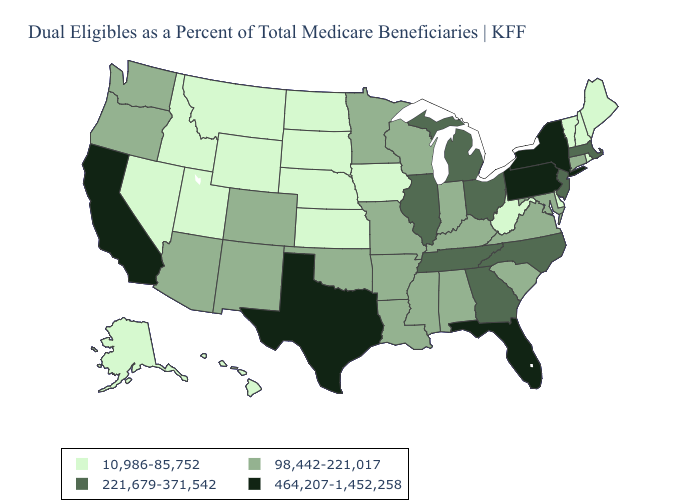Name the states that have a value in the range 221,679-371,542?
Answer briefly. Georgia, Illinois, Massachusetts, Michigan, New Jersey, North Carolina, Ohio, Tennessee. Does the map have missing data?
Quick response, please. No. Among the states that border Colorado , which have the highest value?
Answer briefly. Arizona, New Mexico, Oklahoma. What is the highest value in the USA?
Be succinct. 464,207-1,452,258. What is the lowest value in the South?
Concise answer only. 10,986-85,752. What is the lowest value in the West?
Be succinct. 10,986-85,752. What is the value of Alaska?
Keep it brief. 10,986-85,752. Among the states that border North Carolina , which have the highest value?
Give a very brief answer. Georgia, Tennessee. What is the value of Delaware?
Short answer required. 10,986-85,752. What is the value of New York?
Be succinct. 464,207-1,452,258. Which states have the highest value in the USA?
Be succinct. California, Florida, New York, Pennsylvania, Texas. Name the states that have a value in the range 221,679-371,542?
Short answer required. Georgia, Illinois, Massachusetts, Michigan, New Jersey, North Carolina, Ohio, Tennessee. What is the value of West Virginia?
Short answer required. 10,986-85,752. Name the states that have a value in the range 221,679-371,542?
Be succinct. Georgia, Illinois, Massachusetts, Michigan, New Jersey, North Carolina, Ohio, Tennessee. What is the value of Vermont?
Write a very short answer. 10,986-85,752. 